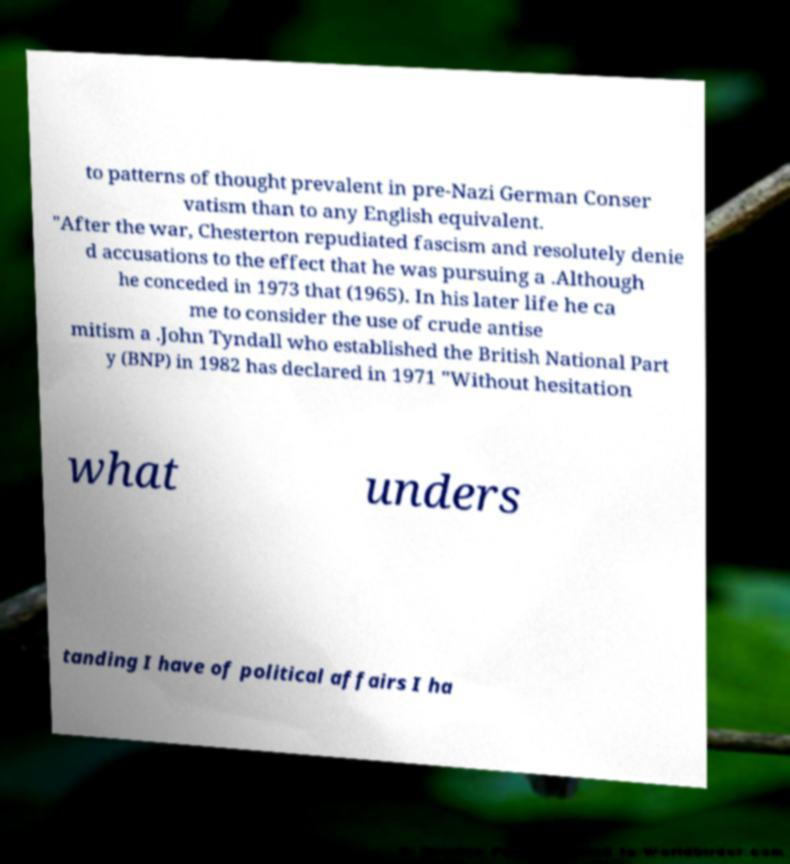There's text embedded in this image that I need extracted. Can you transcribe it verbatim? to patterns of thought prevalent in pre-Nazi German Conser vatism than to any English equivalent. "After the war, Chesterton repudiated fascism and resolutely denie d accusations to the effect that he was pursuing a .Although he conceded in 1973 that (1965). In his later life he ca me to consider the use of crude antise mitism a .John Tyndall who established the British National Part y (BNP) in 1982 has declared in 1971 "Without hesitation what unders tanding I have of political affairs I ha 